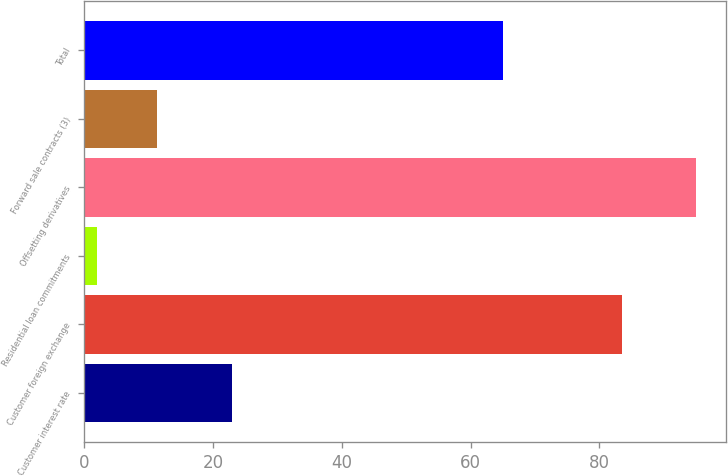Convert chart to OTSL. <chart><loc_0><loc_0><loc_500><loc_500><bar_chart><fcel>Customer interest rate<fcel>Customer foreign exchange<fcel>Residential loan commitments<fcel>Offsetting derivatives<fcel>Forward sale contracts (3)<fcel>Total<nl><fcel>23<fcel>83.6<fcel>2<fcel>95<fcel>11.3<fcel>65<nl></chart> 